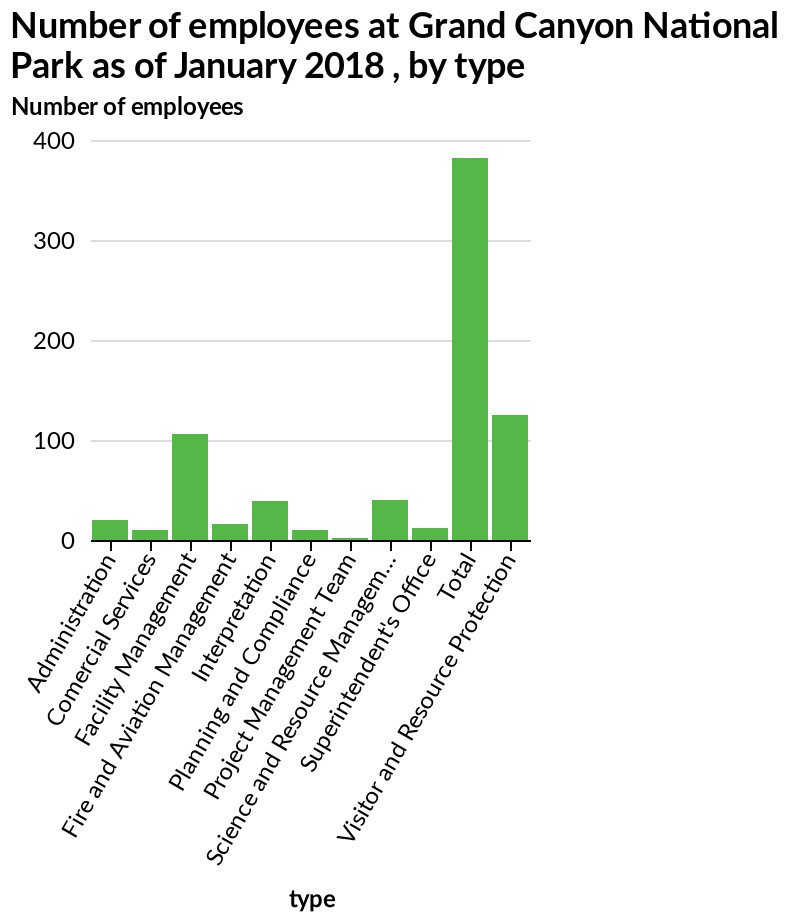<image>
In which sector does the majority of employees work? The majority of employees work in the visitor and resource protection sector. 